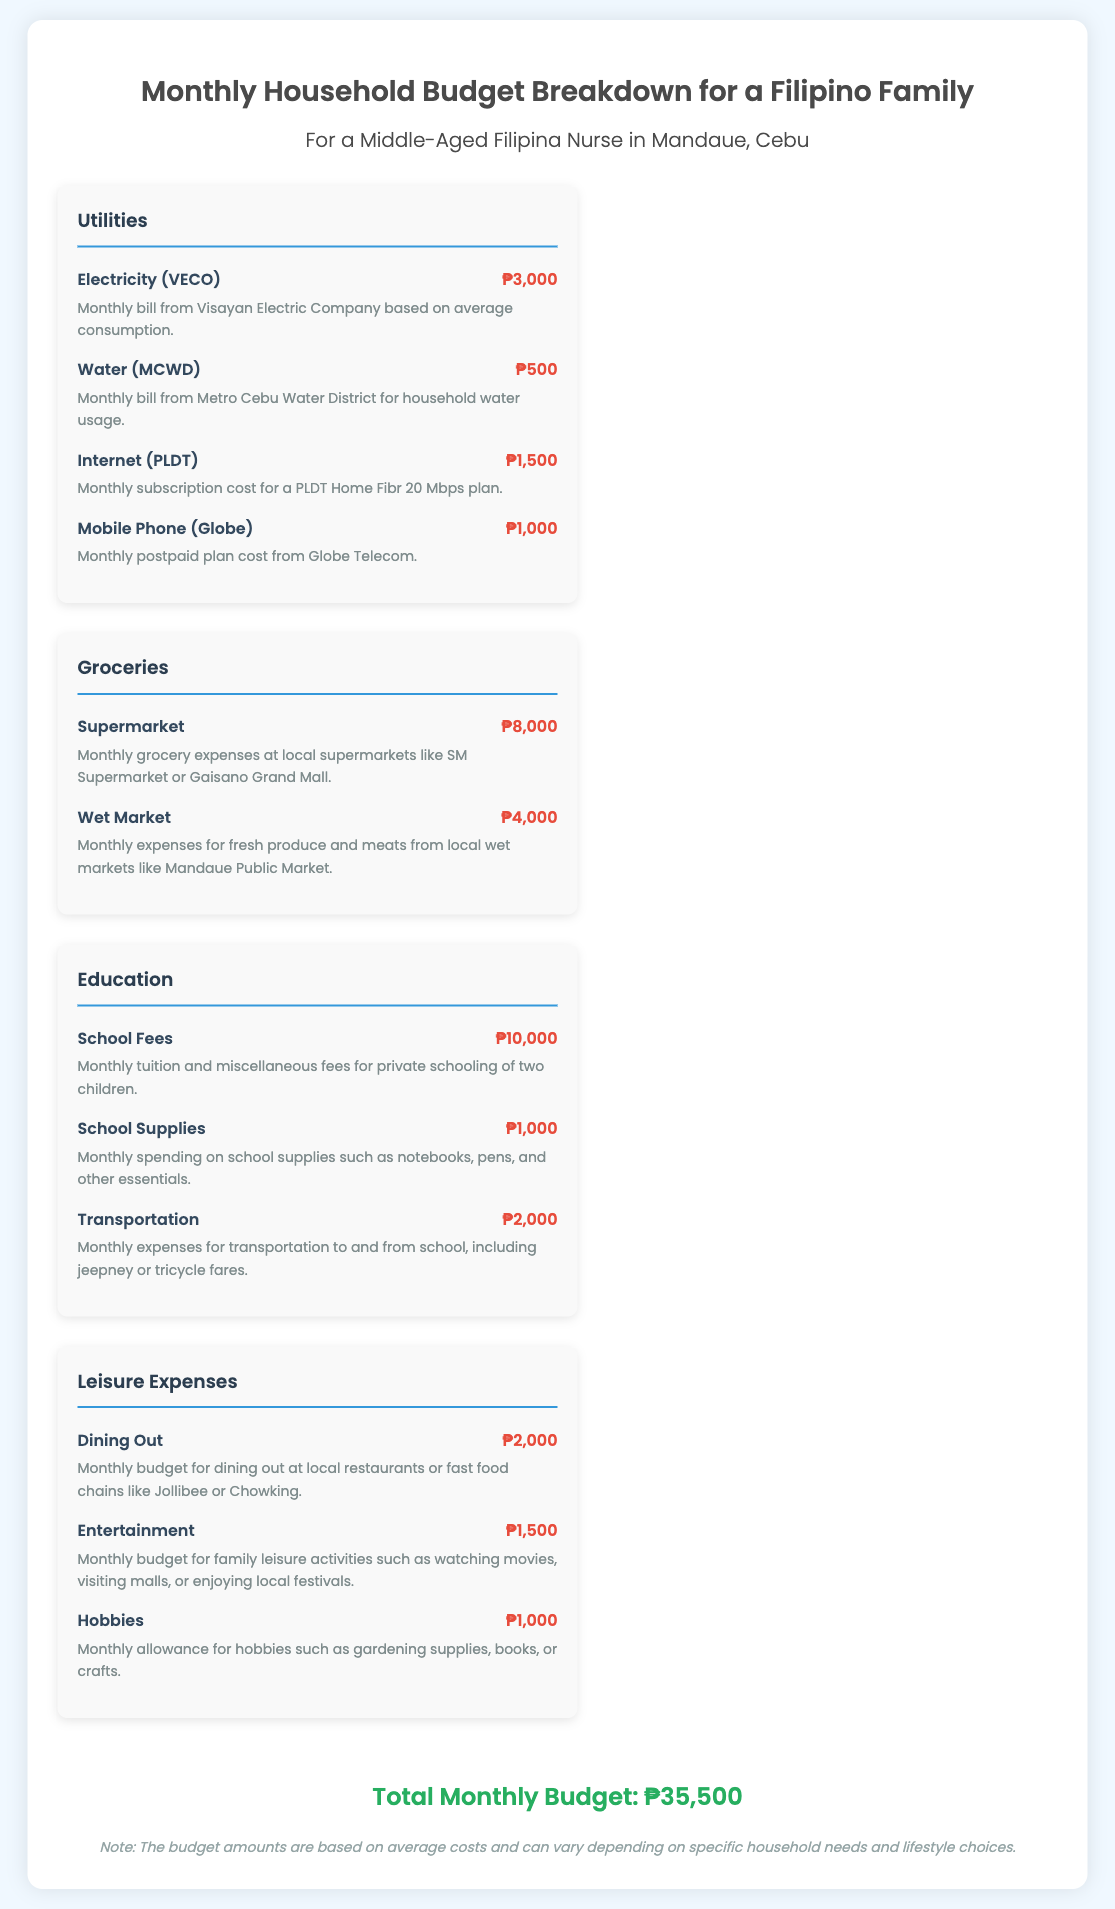What is the total monthly budget? The total monthly budget is displayed at the bottom of the document, which aggregates all expenses categories.
Answer: ₱35,500 How much is spent on electricity? The specific expense for electricity is listed in the Utilities category under Electricity (VECO).
Answer: ₱3,000 What is the monthly grocery expense at the supermarket? The supermarket expense is detailed under the Groceries category.
Answer: ₱8,000 What are the school fees for education expenses? School fees are outlined in the Education category as part of the total education expenses.
Answer: ₱10,000 Which category includes dining out expenses? The dining out expenses are categorized under Leisure Expenses in the document.
Answer: Leisure Expenses How much is allocated for school supplies? The amount allocated for school supplies is indicated under the Education category.
Answer: ₱1,000 What is the expense for water in the Utilities category? The water expense is specified in the Utilities section for water service.
Answer: ₱500 How much is the budget for entertainment? The budget for entertainment is included in the Leisure Expenses section of the document.
Answer: ₱1,500 What is included in the leisure expenses budget? The leisure expenses include various activities such as dining out, entertainment, and hobbies.
Answer: Dining out, Entertainment, Hobbies 